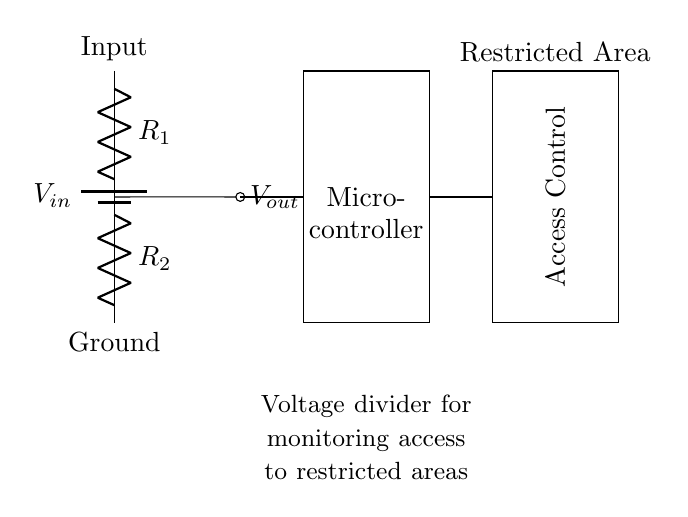What is the input voltage of the circuit? The input voltage, denoted as V_in in the circuit, is the potential difference supplied by the battery, which powers the voltage divider.
Answer: V_in What components are part of the voltage divider? The voltage divider consists of two resistors, R_1 and R_2, connected in series, which divides the voltage across them.
Answer: R_1 and R_2 What is the output voltage of the voltage divider? The output voltage, labeled as V_out, is taken from the junction of the two resistors and can be calculated based on the values of R_1 and R_2 and V_in.
Answer: V_out What is the purpose of the microcontroller in this circuit? The microcontroller receives V_out to process the voltage and control the access based on the voltage level it reads, thereby implementing monitoring.
Answer: Monitoring How does the voltage divider affect access control? The voltage divider allows monitoring of the voltage level, which informs the microcontroller whether the access control device should be activated or deactivated based on the output voltage.
Answer: Controls access What would happen if R_1 is decreased? Decreasing R_1 would increase V_out (thus changing the voltage levels), since a smaller resistance allows more current to flow through the divider, influencing the control logic in the microcontroller.
Answer: Increase V_out Where does the output voltage connect in the circuit? The output voltage V_out is connected to the microcontroller, allowing it to read the voltage value from the voltage divider and make decisions for the access control.
Answer: Microcontroller 